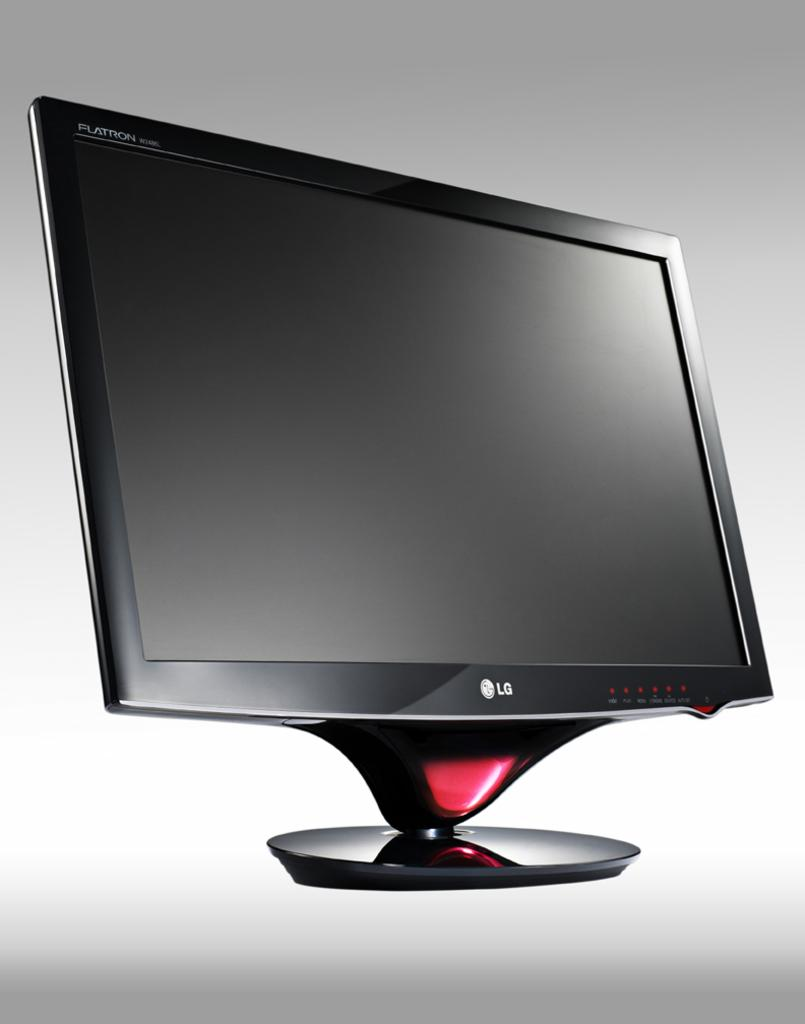<image>
Present a compact description of the photo's key features. A black LG computer screen with red dots on the lower right hand corner. 